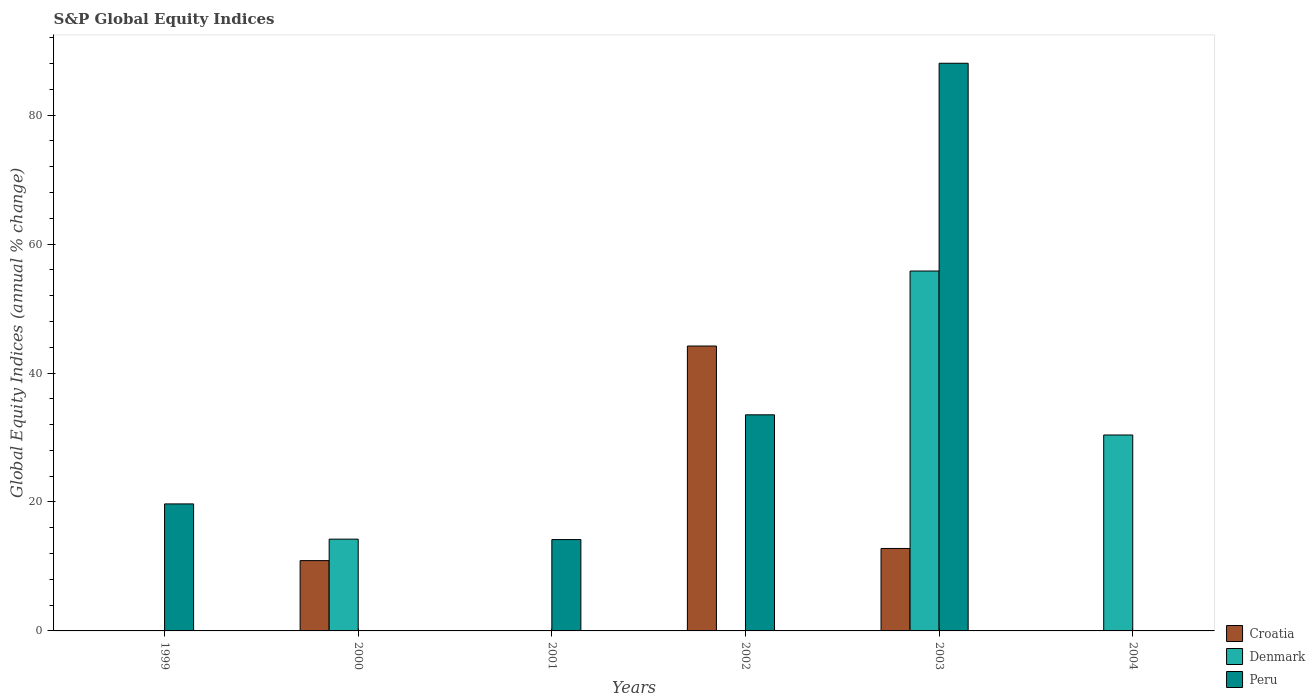How many different coloured bars are there?
Give a very brief answer. 3. Are the number of bars per tick equal to the number of legend labels?
Provide a succinct answer. No. How many bars are there on the 1st tick from the left?
Provide a succinct answer. 1. What is the label of the 6th group of bars from the left?
Provide a succinct answer. 2004. In how many cases, is the number of bars for a given year not equal to the number of legend labels?
Offer a terse response. 5. Across all years, what is the maximum global equity indices in Denmark?
Offer a very short reply. 55.82. In which year was the global equity indices in Denmark maximum?
Give a very brief answer. 2003. What is the total global equity indices in Peru in the graph?
Provide a short and direct response. 155.44. What is the difference between the global equity indices in Peru in 2001 and that in 2003?
Offer a very short reply. -73.88. What is the difference between the global equity indices in Peru in 2000 and the global equity indices in Denmark in 2002?
Keep it short and to the point. 0. What is the average global equity indices in Denmark per year?
Make the answer very short. 16.74. In the year 2003, what is the difference between the global equity indices in Peru and global equity indices in Croatia?
Make the answer very short. 75.26. In how many years, is the global equity indices in Peru greater than 84 %?
Give a very brief answer. 1. What is the ratio of the global equity indices in Denmark in 2000 to that in 2003?
Your answer should be very brief. 0.25. Is the global equity indices in Peru in 2002 less than that in 2003?
Provide a succinct answer. Yes. What is the difference between the highest and the second highest global equity indices in Croatia?
Keep it short and to the point. 31.4. What is the difference between the highest and the lowest global equity indices in Croatia?
Your answer should be very brief. 44.19. Is the sum of the global equity indices in Peru in 1999 and 2002 greater than the maximum global equity indices in Croatia across all years?
Your response must be concise. Yes. Is it the case that in every year, the sum of the global equity indices in Denmark and global equity indices in Peru is greater than the global equity indices in Croatia?
Offer a terse response. No. How many bars are there?
Your answer should be very brief. 10. How many years are there in the graph?
Give a very brief answer. 6. What is the difference between two consecutive major ticks on the Y-axis?
Provide a succinct answer. 20. Are the values on the major ticks of Y-axis written in scientific E-notation?
Keep it short and to the point. No. Where does the legend appear in the graph?
Provide a short and direct response. Bottom right. How many legend labels are there?
Provide a succinct answer. 3. How are the legend labels stacked?
Your response must be concise. Vertical. What is the title of the graph?
Give a very brief answer. S&P Global Equity Indices. Does "Peru" appear as one of the legend labels in the graph?
Give a very brief answer. Yes. What is the label or title of the X-axis?
Ensure brevity in your answer.  Years. What is the label or title of the Y-axis?
Ensure brevity in your answer.  Global Equity Indices (annual % change). What is the Global Equity Indices (annual % change) in Croatia in 1999?
Provide a succinct answer. 0. What is the Global Equity Indices (annual % change) of Peru in 1999?
Provide a succinct answer. 19.7. What is the Global Equity Indices (annual % change) of Croatia in 2000?
Ensure brevity in your answer.  10.9. What is the Global Equity Indices (annual % change) of Denmark in 2000?
Offer a terse response. 14.23. What is the Global Equity Indices (annual % change) of Peru in 2000?
Provide a short and direct response. 0. What is the Global Equity Indices (annual % change) of Croatia in 2001?
Your answer should be very brief. 0. What is the Global Equity Indices (annual % change) of Peru in 2001?
Your answer should be compact. 14.17. What is the Global Equity Indices (annual % change) in Croatia in 2002?
Offer a very short reply. 44.19. What is the Global Equity Indices (annual % change) of Denmark in 2002?
Your answer should be compact. 0. What is the Global Equity Indices (annual % change) in Peru in 2002?
Ensure brevity in your answer.  33.52. What is the Global Equity Indices (annual % change) in Croatia in 2003?
Provide a succinct answer. 12.79. What is the Global Equity Indices (annual % change) in Denmark in 2003?
Your answer should be compact. 55.82. What is the Global Equity Indices (annual % change) in Peru in 2003?
Offer a terse response. 88.05. What is the Global Equity Indices (annual % change) in Denmark in 2004?
Give a very brief answer. 30.39. What is the Global Equity Indices (annual % change) in Peru in 2004?
Your answer should be very brief. 0. Across all years, what is the maximum Global Equity Indices (annual % change) in Croatia?
Your response must be concise. 44.19. Across all years, what is the maximum Global Equity Indices (annual % change) in Denmark?
Give a very brief answer. 55.82. Across all years, what is the maximum Global Equity Indices (annual % change) in Peru?
Offer a terse response. 88.05. Across all years, what is the minimum Global Equity Indices (annual % change) in Croatia?
Ensure brevity in your answer.  0. Across all years, what is the minimum Global Equity Indices (annual % change) in Denmark?
Ensure brevity in your answer.  0. What is the total Global Equity Indices (annual % change) in Croatia in the graph?
Your answer should be very brief. 67.88. What is the total Global Equity Indices (annual % change) of Denmark in the graph?
Provide a succinct answer. 100.45. What is the total Global Equity Indices (annual % change) of Peru in the graph?
Provide a succinct answer. 155.44. What is the difference between the Global Equity Indices (annual % change) of Peru in 1999 and that in 2001?
Make the answer very short. 5.53. What is the difference between the Global Equity Indices (annual % change) in Peru in 1999 and that in 2002?
Keep it short and to the point. -13.82. What is the difference between the Global Equity Indices (annual % change) of Peru in 1999 and that in 2003?
Offer a very short reply. -68.35. What is the difference between the Global Equity Indices (annual % change) of Croatia in 2000 and that in 2002?
Keep it short and to the point. -33.29. What is the difference between the Global Equity Indices (annual % change) of Croatia in 2000 and that in 2003?
Your answer should be compact. -1.89. What is the difference between the Global Equity Indices (annual % change) in Denmark in 2000 and that in 2003?
Your answer should be compact. -41.59. What is the difference between the Global Equity Indices (annual % change) in Denmark in 2000 and that in 2004?
Offer a terse response. -16.16. What is the difference between the Global Equity Indices (annual % change) in Peru in 2001 and that in 2002?
Provide a succinct answer. -19.35. What is the difference between the Global Equity Indices (annual % change) of Peru in 2001 and that in 2003?
Your response must be concise. -73.88. What is the difference between the Global Equity Indices (annual % change) in Croatia in 2002 and that in 2003?
Make the answer very short. 31.4. What is the difference between the Global Equity Indices (annual % change) of Peru in 2002 and that in 2003?
Offer a terse response. -54.53. What is the difference between the Global Equity Indices (annual % change) of Denmark in 2003 and that in 2004?
Give a very brief answer. 25.43. What is the difference between the Global Equity Indices (annual % change) of Croatia in 2000 and the Global Equity Indices (annual % change) of Peru in 2001?
Make the answer very short. -3.27. What is the difference between the Global Equity Indices (annual % change) in Denmark in 2000 and the Global Equity Indices (annual % change) in Peru in 2001?
Your response must be concise. 0.06. What is the difference between the Global Equity Indices (annual % change) in Croatia in 2000 and the Global Equity Indices (annual % change) in Peru in 2002?
Provide a short and direct response. -22.62. What is the difference between the Global Equity Indices (annual % change) of Denmark in 2000 and the Global Equity Indices (annual % change) of Peru in 2002?
Keep it short and to the point. -19.29. What is the difference between the Global Equity Indices (annual % change) of Croatia in 2000 and the Global Equity Indices (annual % change) of Denmark in 2003?
Make the answer very short. -44.92. What is the difference between the Global Equity Indices (annual % change) of Croatia in 2000 and the Global Equity Indices (annual % change) of Peru in 2003?
Provide a succinct answer. -77.15. What is the difference between the Global Equity Indices (annual % change) of Denmark in 2000 and the Global Equity Indices (annual % change) of Peru in 2003?
Provide a short and direct response. -73.82. What is the difference between the Global Equity Indices (annual % change) of Croatia in 2000 and the Global Equity Indices (annual % change) of Denmark in 2004?
Offer a terse response. -19.49. What is the difference between the Global Equity Indices (annual % change) in Croatia in 2002 and the Global Equity Indices (annual % change) in Denmark in 2003?
Give a very brief answer. -11.63. What is the difference between the Global Equity Indices (annual % change) of Croatia in 2002 and the Global Equity Indices (annual % change) of Peru in 2003?
Give a very brief answer. -43.86. What is the difference between the Global Equity Indices (annual % change) in Croatia in 2002 and the Global Equity Indices (annual % change) in Denmark in 2004?
Provide a short and direct response. 13.8. What is the difference between the Global Equity Indices (annual % change) of Croatia in 2003 and the Global Equity Indices (annual % change) of Denmark in 2004?
Provide a succinct answer. -17.6. What is the average Global Equity Indices (annual % change) of Croatia per year?
Offer a terse response. 11.31. What is the average Global Equity Indices (annual % change) of Denmark per year?
Your answer should be compact. 16.74. What is the average Global Equity Indices (annual % change) of Peru per year?
Keep it short and to the point. 25.91. In the year 2000, what is the difference between the Global Equity Indices (annual % change) in Croatia and Global Equity Indices (annual % change) in Denmark?
Offer a terse response. -3.33. In the year 2002, what is the difference between the Global Equity Indices (annual % change) of Croatia and Global Equity Indices (annual % change) of Peru?
Provide a succinct answer. 10.67. In the year 2003, what is the difference between the Global Equity Indices (annual % change) of Croatia and Global Equity Indices (annual % change) of Denmark?
Provide a short and direct response. -43.03. In the year 2003, what is the difference between the Global Equity Indices (annual % change) in Croatia and Global Equity Indices (annual % change) in Peru?
Your response must be concise. -75.26. In the year 2003, what is the difference between the Global Equity Indices (annual % change) in Denmark and Global Equity Indices (annual % change) in Peru?
Your response must be concise. -32.23. What is the ratio of the Global Equity Indices (annual % change) in Peru in 1999 to that in 2001?
Offer a very short reply. 1.39. What is the ratio of the Global Equity Indices (annual % change) in Peru in 1999 to that in 2002?
Keep it short and to the point. 0.59. What is the ratio of the Global Equity Indices (annual % change) in Peru in 1999 to that in 2003?
Your response must be concise. 0.22. What is the ratio of the Global Equity Indices (annual % change) of Croatia in 2000 to that in 2002?
Offer a very short reply. 0.25. What is the ratio of the Global Equity Indices (annual % change) of Croatia in 2000 to that in 2003?
Your answer should be very brief. 0.85. What is the ratio of the Global Equity Indices (annual % change) in Denmark in 2000 to that in 2003?
Keep it short and to the point. 0.26. What is the ratio of the Global Equity Indices (annual % change) of Denmark in 2000 to that in 2004?
Your answer should be compact. 0.47. What is the ratio of the Global Equity Indices (annual % change) of Peru in 2001 to that in 2002?
Offer a very short reply. 0.42. What is the ratio of the Global Equity Indices (annual % change) of Peru in 2001 to that in 2003?
Ensure brevity in your answer.  0.16. What is the ratio of the Global Equity Indices (annual % change) of Croatia in 2002 to that in 2003?
Your response must be concise. 3.46. What is the ratio of the Global Equity Indices (annual % change) of Peru in 2002 to that in 2003?
Provide a short and direct response. 0.38. What is the ratio of the Global Equity Indices (annual % change) of Denmark in 2003 to that in 2004?
Ensure brevity in your answer.  1.84. What is the difference between the highest and the second highest Global Equity Indices (annual % change) in Croatia?
Your answer should be compact. 31.4. What is the difference between the highest and the second highest Global Equity Indices (annual % change) of Denmark?
Give a very brief answer. 25.43. What is the difference between the highest and the second highest Global Equity Indices (annual % change) in Peru?
Give a very brief answer. 54.53. What is the difference between the highest and the lowest Global Equity Indices (annual % change) in Croatia?
Offer a very short reply. 44.19. What is the difference between the highest and the lowest Global Equity Indices (annual % change) of Denmark?
Ensure brevity in your answer.  55.82. What is the difference between the highest and the lowest Global Equity Indices (annual % change) in Peru?
Offer a terse response. 88.05. 